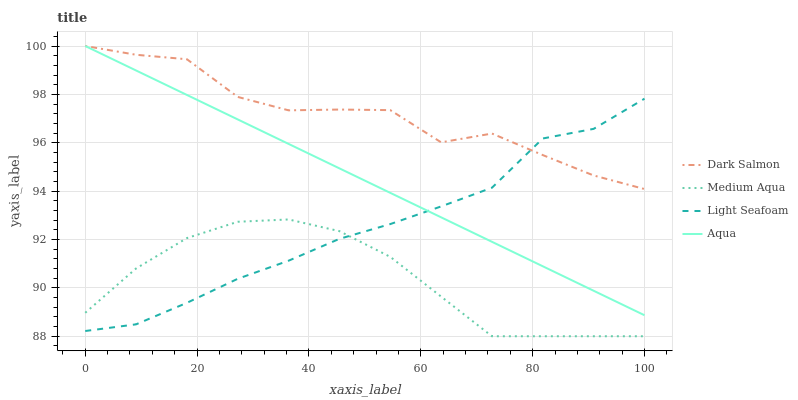Does Medium Aqua have the minimum area under the curve?
Answer yes or no. Yes. Does Dark Salmon have the maximum area under the curve?
Answer yes or no. Yes. Does Light Seafoam have the minimum area under the curve?
Answer yes or no. No. Does Light Seafoam have the maximum area under the curve?
Answer yes or no. No. Is Aqua the smoothest?
Answer yes or no. Yes. Is Dark Salmon the roughest?
Answer yes or no. Yes. Is Light Seafoam the smoothest?
Answer yes or no. No. Is Light Seafoam the roughest?
Answer yes or no. No. Does Medium Aqua have the lowest value?
Answer yes or no. Yes. Does Light Seafoam have the lowest value?
Answer yes or no. No. Does Dark Salmon have the highest value?
Answer yes or no. Yes. Does Light Seafoam have the highest value?
Answer yes or no. No. Is Medium Aqua less than Dark Salmon?
Answer yes or no. Yes. Is Dark Salmon greater than Medium Aqua?
Answer yes or no. Yes. Does Medium Aqua intersect Light Seafoam?
Answer yes or no. Yes. Is Medium Aqua less than Light Seafoam?
Answer yes or no. No. Is Medium Aqua greater than Light Seafoam?
Answer yes or no. No. Does Medium Aqua intersect Dark Salmon?
Answer yes or no. No. 